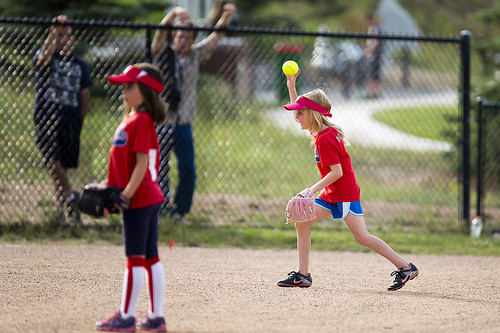<image>
Is there a fence in front of the ball? Yes. The fence is positioned in front of the ball, appearing closer to the camera viewpoint. 